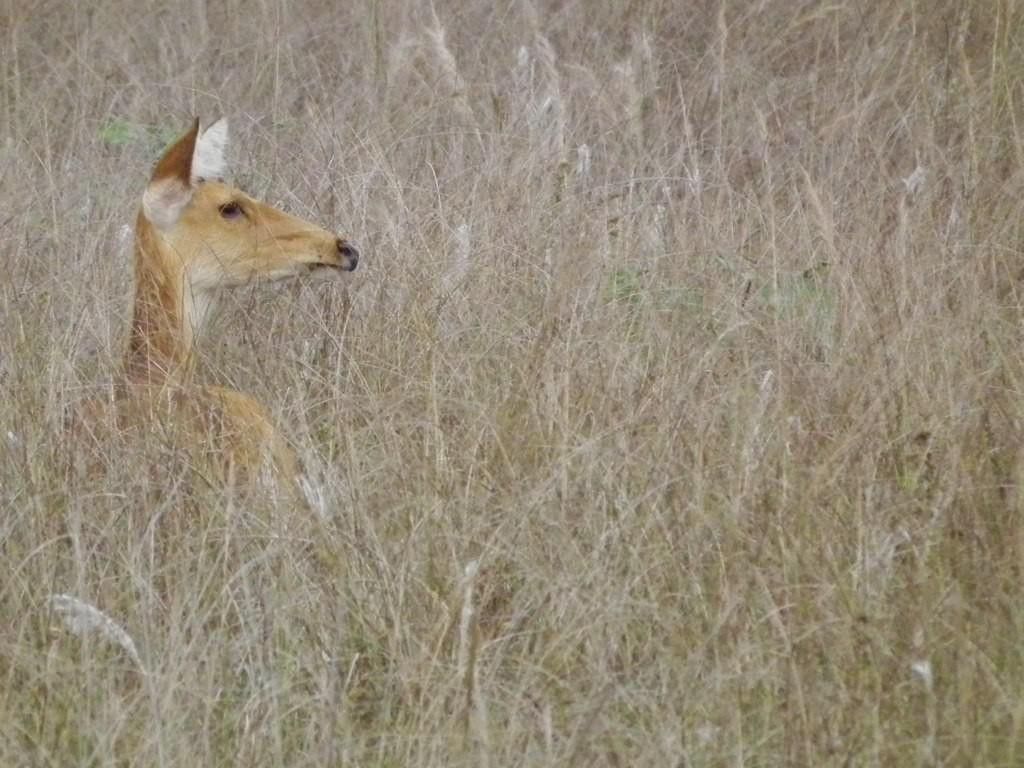What is the primary feature of the landscape in the image? There is a lot of grass in the image. Can you describe any living creatures in the image? There is an animal in the grass. What type of cloud can be seen in the image? There is no cloud visible in the image; it only features grass and an animal. Can you describe the arm of the animal in the image? There is no arm visible in the image, as the animal is not a human or a creature with limbs like a human. 